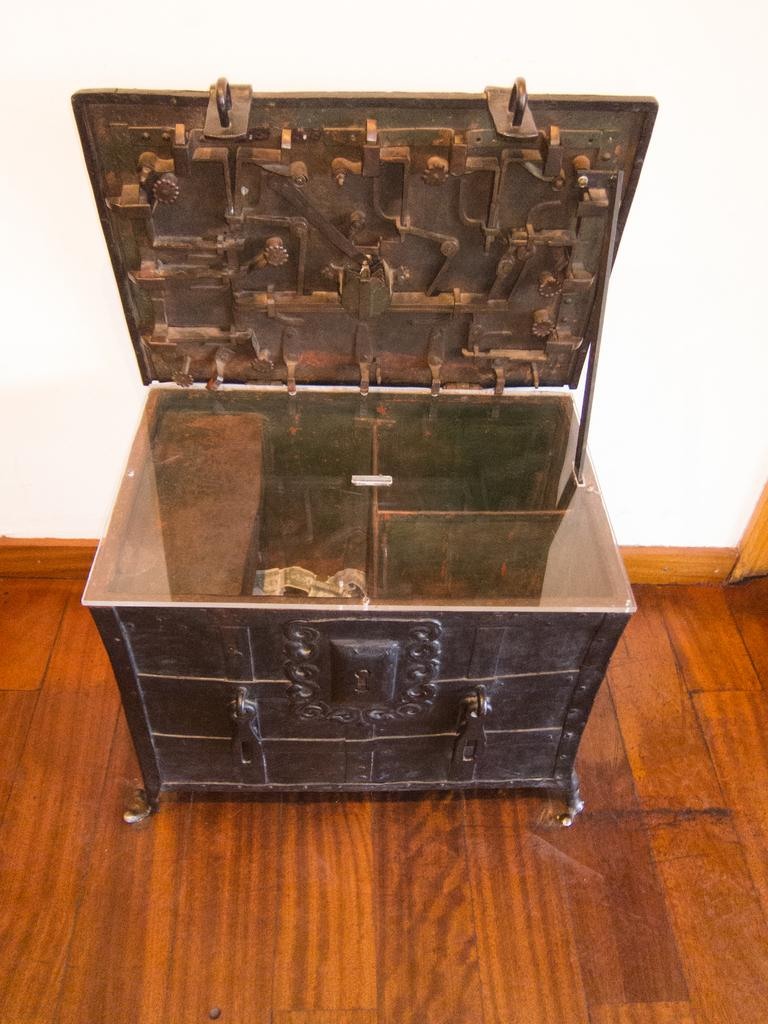What object is present in the image? There is a box in the image. What type of surface is the box resting on? The box is on a wooden floor. What can be seen in the background of the image? There is a wall visible in the background of the image. What type of mitten is the duck wearing in the image? There is no duck or mitten present in the image. What type of drug is being stored in the box in the image? There is no drug present in the image; it is just a box on a wooden floor with a wall visible in the background. 